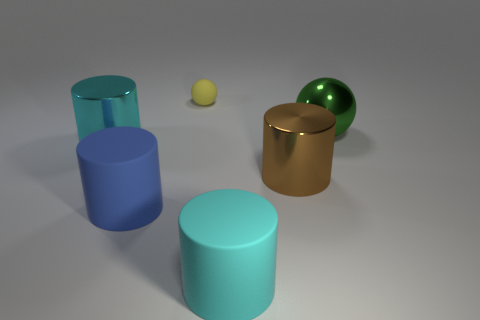How many other things are there of the same material as the big brown cylinder? 2 